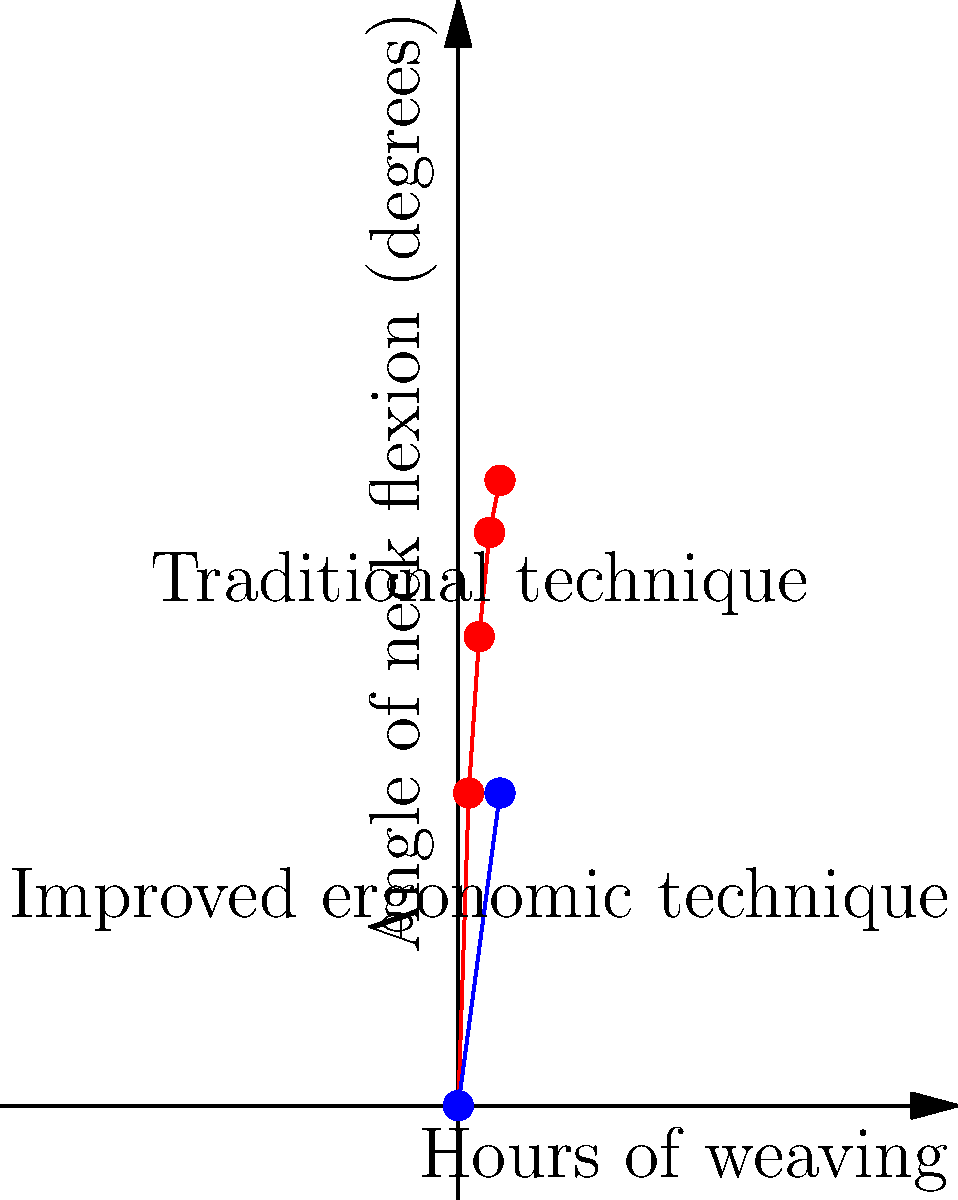Based on the graph showing the relationship between hours of weaving and neck flexion angle for traditional and improved ergonomic techniques, what is the approximate difference in neck flexion angle between the two techniques after 3 hours of weaving? To solve this problem, we need to follow these steps:

1. Identify the neck flexion angle for the traditional technique at 3 hours:
   From the red line, we can see that at 3 hours, the angle is approximately 55 degrees.

2. Identify the neck flexion angle for the improved ergonomic technique at 3 hours:
   From the blue line, we can estimate that at 3 hours, the angle is approximately 22.5 degrees.

3. Calculate the difference between the two angles:
   $55^\circ - 22.5^\circ = 32.5^\circ$

Therefore, the approximate difference in neck flexion angle between the traditional and improved ergonomic techniques after 3 hours of weaving is 32.5 degrees.
Answer: 32.5 degrees 